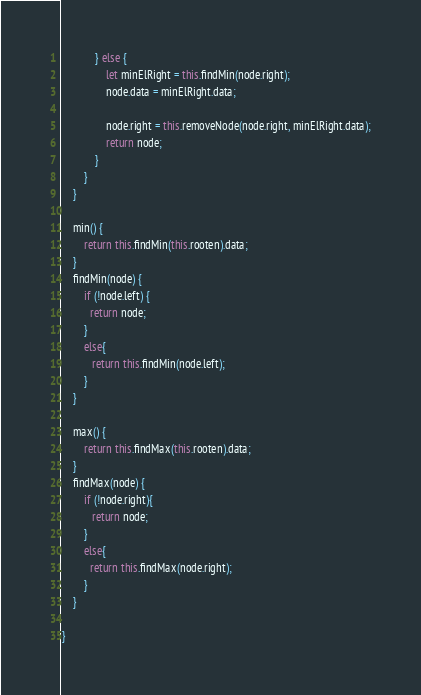<code> <loc_0><loc_0><loc_500><loc_500><_JavaScript_>            } else {
                let minElRight = this.findMin(node.right);
                node.data = minElRight.data;

                node.right = this.removeNode(node.right, minElRight.data);
                return node;
            }
        }
    }

    min() {
        return this.findMin(this.rooten).data;
    }
    findMin(node) {
        if (!node.left) {
          return node;
        }
        else{
           return this.findMin(node.left);
        }
    }

    max() {
        return this.findMax(this.rooten).data;
    }
    findMax(node) {
        if (!node.right){
           return node;
        }
        else{
          return this.findMax(node.right);
        } 
    }

}</code> 